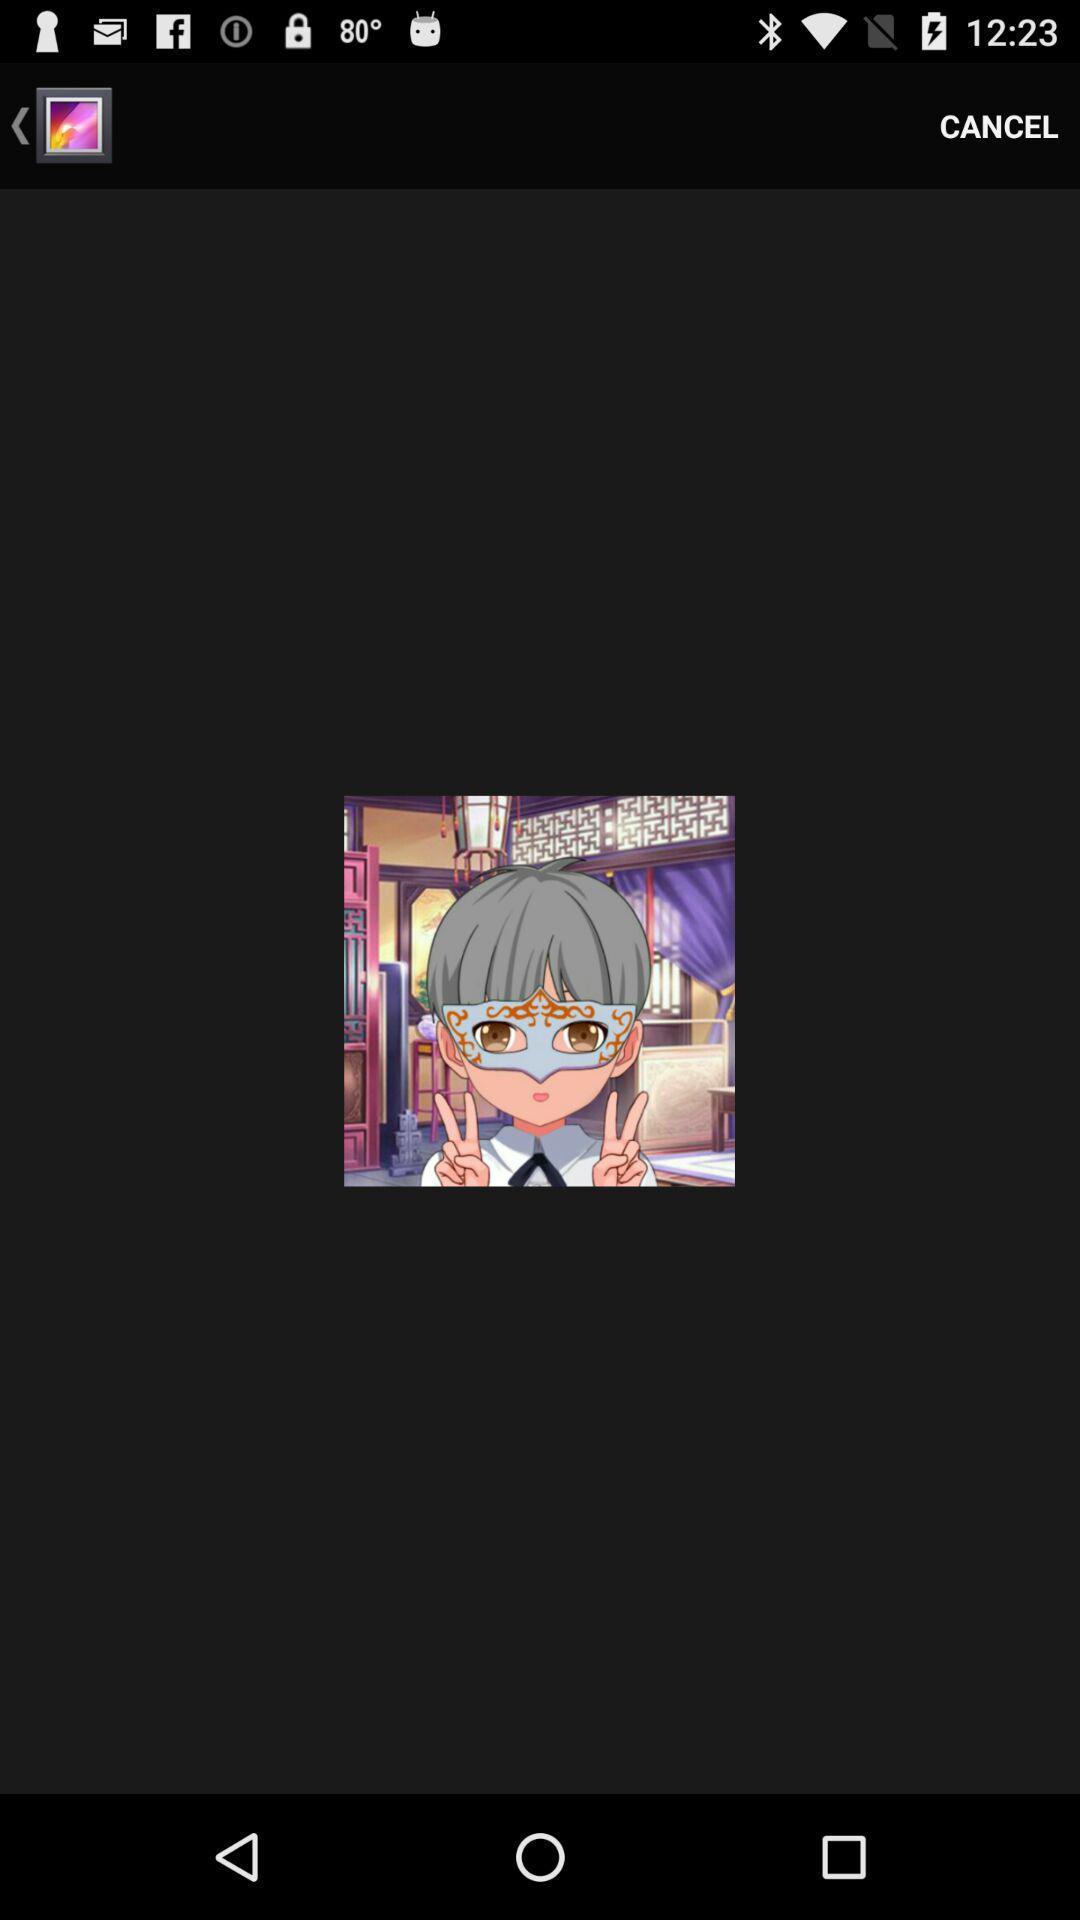Describe the visual elements of this screenshot. Page displaying an image with cancel option. 